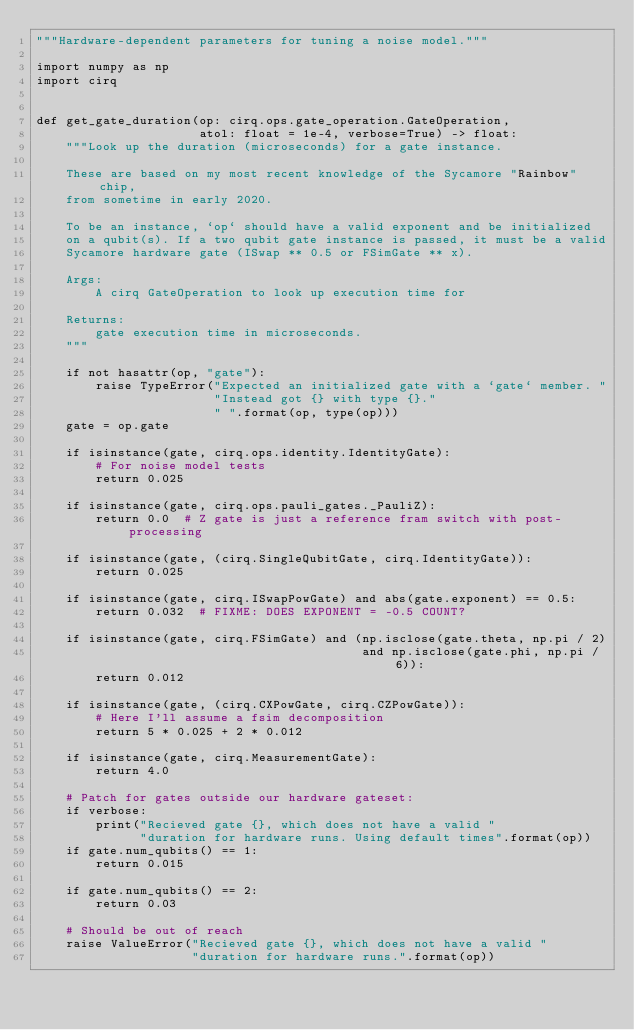Convert code to text. <code><loc_0><loc_0><loc_500><loc_500><_Python_>"""Hardware-dependent parameters for tuning a noise model."""

import numpy as np
import cirq


def get_gate_duration(op: cirq.ops.gate_operation.GateOperation,
                      atol: float = 1e-4, verbose=True) -> float:
    """Look up the duration (microseconds) for a gate instance.

    These are based on my most recent knowledge of the Sycamore "Rainbow" chip,
    from sometime in early 2020.

    To be an instance, `op` should have a valid exponent and be initialized
    on a qubit(s). If a two qubit gate instance is passed, it must be a valid
    Sycamore hardware gate (ISwap ** 0.5 or FSimGate ** x).

    Args:
        A cirq GateOperation to look up execution time for

    Returns:
        gate execution time in microseconds.
    """

    if not hasattr(op, "gate"):
        raise TypeError("Expected an initialized gate with a `gate` member. "
                        "Instead got {} with type {}."
                        " ".format(op, type(op)))
    gate = op.gate

    if isinstance(gate, cirq.ops.identity.IdentityGate):
        # For noise model tests
        return 0.025

    if isinstance(gate, cirq.ops.pauli_gates._PauliZ):
        return 0.0  # Z gate is just a reference fram switch with post-processing

    if isinstance(gate, (cirq.SingleQubitGate, cirq.IdentityGate)):
        return 0.025

    if isinstance(gate, cirq.ISwapPowGate) and abs(gate.exponent) == 0.5:
        return 0.032  # FIXME: DOES EXPONENT = -0.5 COUNT?

    if isinstance(gate, cirq.FSimGate) and (np.isclose(gate.theta, np.pi / 2)
                                            and np.isclose(gate.phi, np.pi / 6)):
        return 0.012

    if isinstance(gate, (cirq.CXPowGate, cirq.CZPowGate)):
        # Here I'll assume a fsim decomposition
        return 5 * 0.025 + 2 * 0.012

    if isinstance(gate, cirq.MeasurementGate):
        return 4.0

    # Patch for gates outside our hardware gateset:
    if verbose:
        print("Recieved gate {}, which does not have a valid "
              "duration for hardware runs. Using default times".format(op))
    if gate.num_qubits() == 1:
        return 0.015

    if gate.num_qubits() == 2:
        return 0.03

    # Should be out of reach
    raise ValueError("Recieved gate {}, which does not have a valid "
                     "duration for hardware runs.".format(op))</code> 